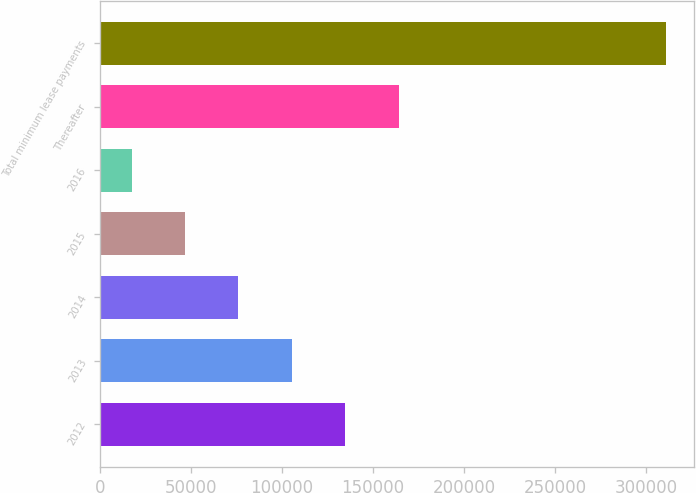<chart> <loc_0><loc_0><loc_500><loc_500><bar_chart><fcel>2012<fcel>2013<fcel>2014<fcel>2015<fcel>2016<fcel>Thereafter<fcel>Total minimum lease payments<nl><fcel>134822<fcel>105479<fcel>76136<fcel>46793<fcel>17450<fcel>164165<fcel>310880<nl></chart> 